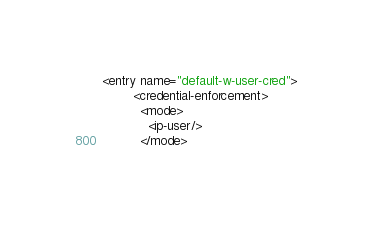<code> <loc_0><loc_0><loc_500><loc_500><_XML_><entry name="default-w-user-cred">
        <credential-enforcement>
          <mode>
            <ip-user/>
          </mode></code> 